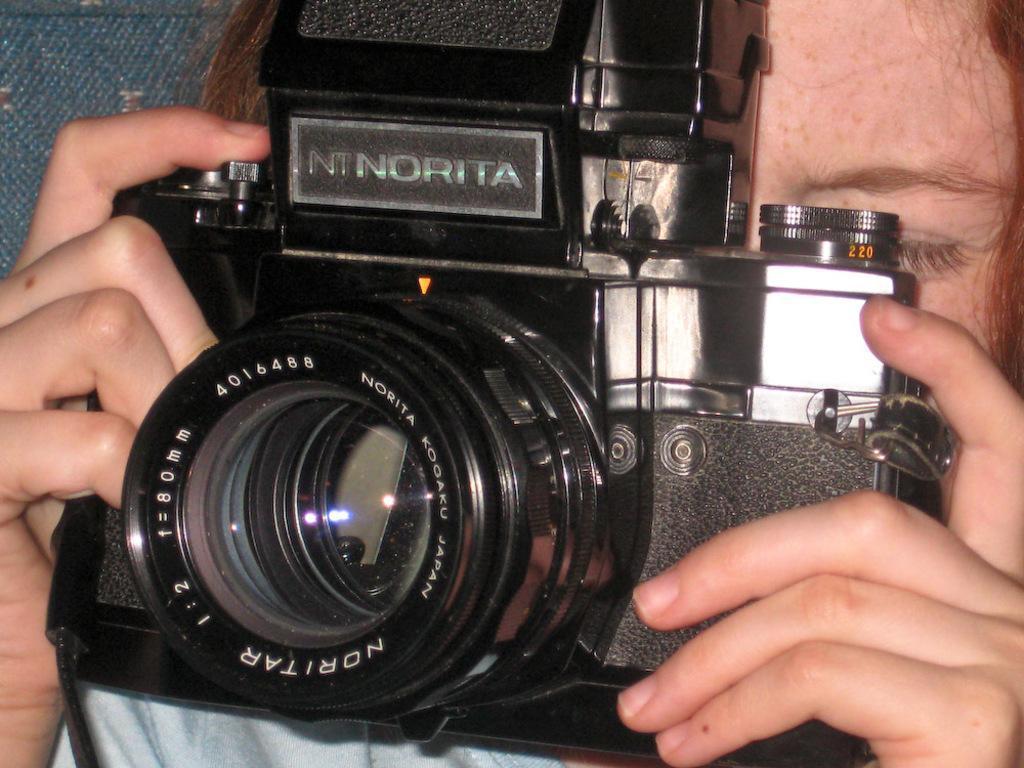How would you summarize this image in a sentence or two? In this image we can see a person holding a camera. 